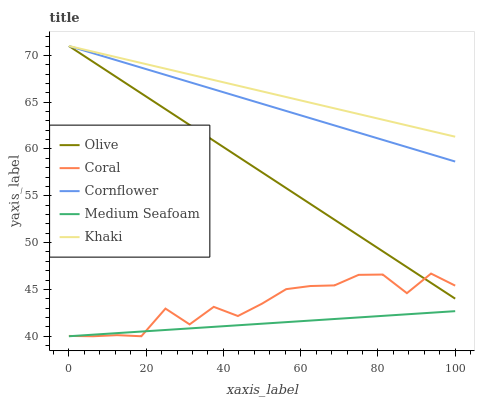Does Medium Seafoam have the minimum area under the curve?
Answer yes or no. Yes. Does Khaki have the maximum area under the curve?
Answer yes or no. Yes. Does Cornflower have the minimum area under the curve?
Answer yes or no. No. Does Cornflower have the maximum area under the curve?
Answer yes or no. No. Is Khaki the smoothest?
Answer yes or no. Yes. Is Coral the roughest?
Answer yes or no. Yes. Is Cornflower the smoothest?
Answer yes or no. No. Is Cornflower the roughest?
Answer yes or no. No. Does Cornflower have the lowest value?
Answer yes or no. No. Does Khaki have the highest value?
Answer yes or no. Yes. Does Coral have the highest value?
Answer yes or no. No. Is Medium Seafoam less than Khaki?
Answer yes or no. Yes. Is Cornflower greater than Medium Seafoam?
Answer yes or no. Yes. Does Olive intersect Khaki?
Answer yes or no. Yes. Is Olive less than Khaki?
Answer yes or no. No. Is Olive greater than Khaki?
Answer yes or no. No. Does Medium Seafoam intersect Khaki?
Answer yes or no. No. 